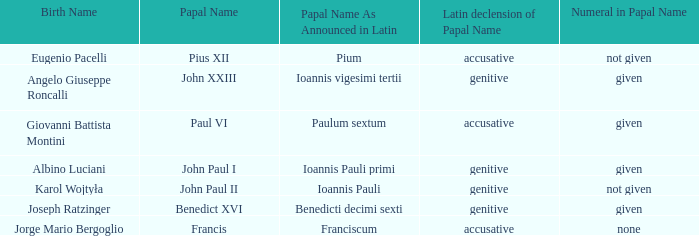For pope paul vi, what is the variation of his papal name? Accusative. 